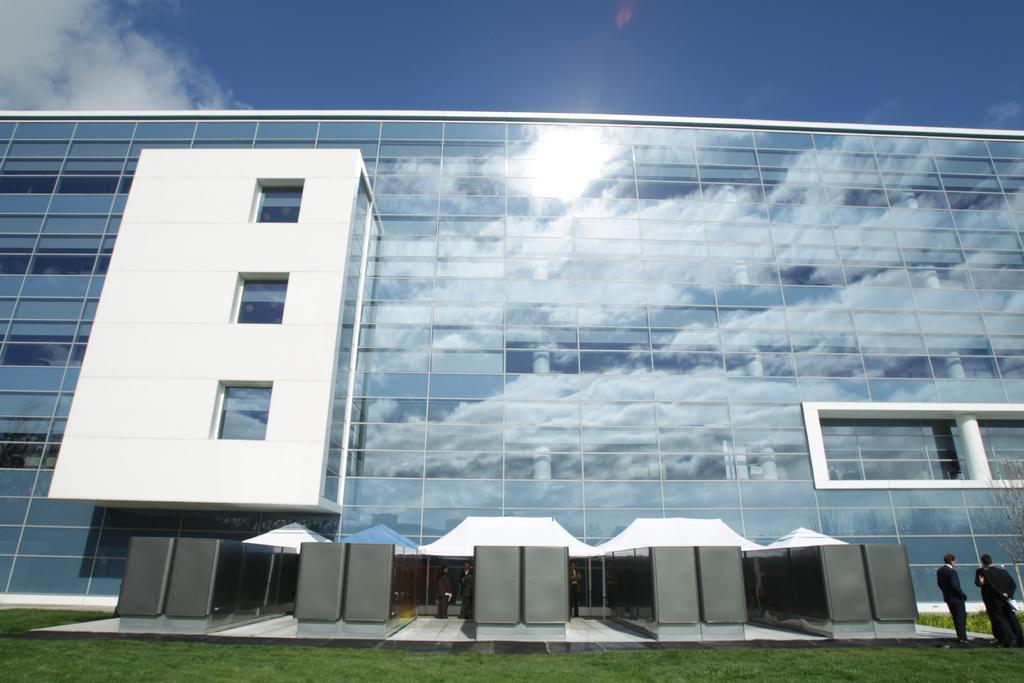How would you summarize this image in a sentence or two? In this image I can see the group of people standing on the ground with black color dresses. To the side I can see the building which is in blue color. I can also see few people under the building. In the back there are clouds and the blue sky. 